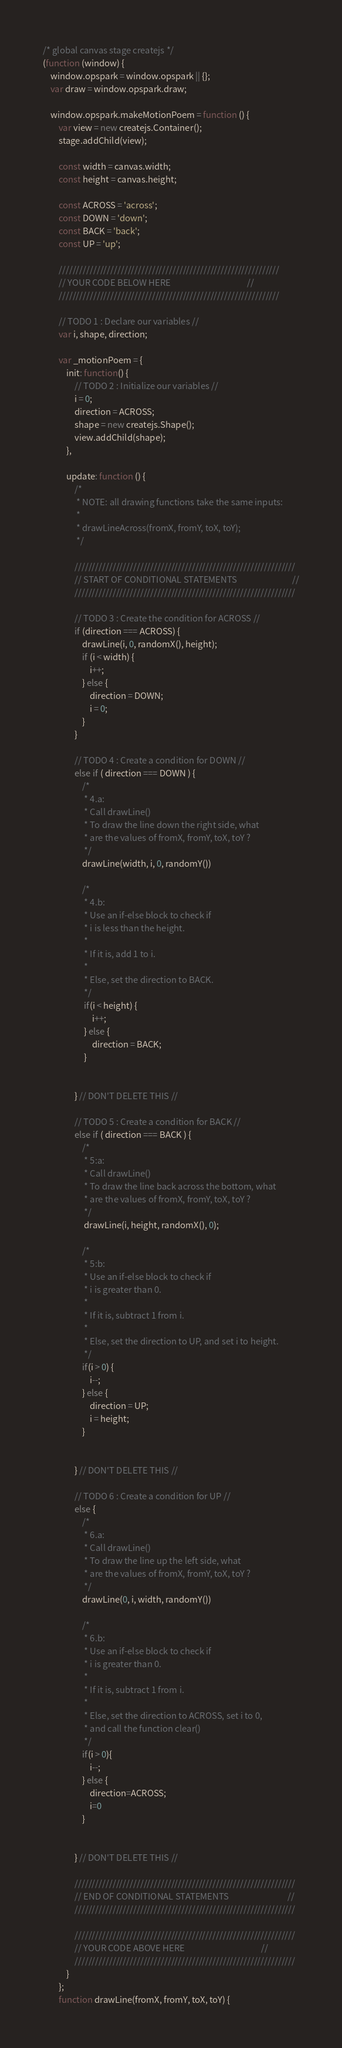<code> <loc_0><loc_0><loc_500><loc_500><_JavaScript_>/* global canvas stage createjs */
(function (window) {
    window.opspark = window.opspark || {};
    var draw = window.opspark.draw;

    window.opspark.makeMotionPoem = function () {
        var view = new createjs.Container();
        stage.addChild(view);

        const width = canvas.width;
        const height = canvas.height;
        
        const ACROSS = 'across';
        const DOWN = 'down';
        const BACK = 'back';
        const UP = 'up';
        
        ////////////////////////////////////////////////////////////////
        // YOUR CODE BELOW HERE                                       //
        ////////////////////////////////////////////////////////////////

        // TODO 1 : Declare our variables //
        var i, shape, direction;

        var _motionPoem = {
            init: function() {
                // TODO 2 : Initialize our variables //
                i = 0;
                direction = ACROSS;
                shape = new createjs.Shape();
                view.addChild(shape);
            },

            update: function () {
                /*
                 * NOTE: all drawing functions take the same inputs:
                 * 
                 * drawLineAcross(fromX, fromY, toX, toY);
                 */
                
                ////////////////////////////////////////////////////////////////
                // START OF CONDITIONAL STATEMENTS                            //
                ////////////////////////////////////////////////////////////////
                
                // TODO 3 : Create the condition for ACROSS //
                if (direction === ACROSS) {
                    drawLine(i, 0, randomX(), height);
                    if (i < width) {
                        i++;
                    } else {
                        direction = DOWN;
                        i = 0;
                    }
                }

                // TODO 4 : Create a condition for DOWN //
                else if ( direction === DOWN ) {
                    /*
                     * 4.a:
                     * Call drawLine()
                     * To draw the line down the right side, what
                     * are the values of fromX, fromY, toX, toY ?
                     */
                    drawLine(width, i, 0, randomY())
                    
                    /*
                     * 4.b:
                     * Use an if-else block to check if 
                     * i is less than the height.
                     * 
                     * If it is, add 1 to i.
                     * 
                     * Else, set the direction to BACK.
                     */
                     if(i < height) {
                         i++;
                     } else {
                         direction = BACK;
                     }
                     
                     
                } // DON'T DELETE THIS //

                // TODO 5 : Create a condition for BACK //
                else if ( direction === BACK ) {
                    /*
                     * 5:a:
                     * Call drawLine()
                     * To draw the line back across the bottom, what
                     * are the values of fromX, fromY, toX, toY ?
                     */
                     drawLine(i, height, randomX(), 0);
                     
                    /*
                     * 5:b:
                     * Use an if-else block to check if
                     * i is greater than 0. 
                     *
                     * If it is, subtract 1 from i.
                     * 
                     * Else, set the direction to UP, and set i to height.
                     */
                    if(i > 0) {
                        i--;
                    } else {
                        direction = UP;
                        i = height;
                    }
                    
                    
                } // DON'T DELETE THIS //

                // TODO 6 : Create a condition for UP //
                else {
                    /*
                     * 6.a:
                     * Call drawLine()
                     * To draw the line up the left side, what
                     * are the values of fromX, fromY, toX, toY ?
                     */
                    drawLine(0, i, width, randomY())
                    
                    /*
                     * 6.b:
                     * Use an if-else block to check if
                     * i is greater than 0.
                     *
                     * If it is, subtract 1 from i.
                     * 
                     * Else, set the direction to ACROSS, set i to 0, 
                     * and call the function clear()
                     */
                    if(i > 0){
                        i--;
                    } else {
                        direction=ACROSS;
                        i=0
                    }
                    
                    
                } // DON'T DELETE THIS //
                
                ////////////////////////////////////////////////////////////////
                // END OF CONDITIONAL STATEMENTS                              //
                ////////////////////////////////////////////////////////////////
                
                ////////////////////////////////////////////////////////////////
                // YOUR CODE ABOVE HERE                                       //
                ////////////////////////////////////////////////////////////////
            }
        };
        function drawLine(fromX, fromY, toX, toY) {</code> 